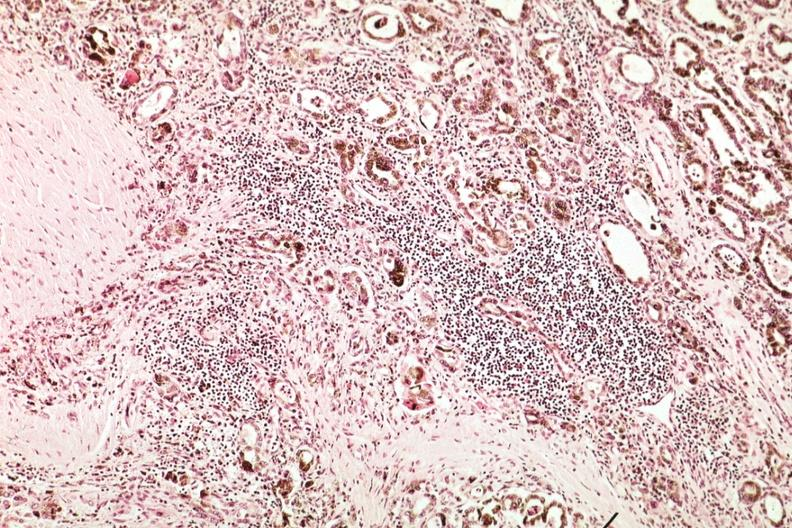what is present?
Answer the question using a single word or phrase. Endocrine 